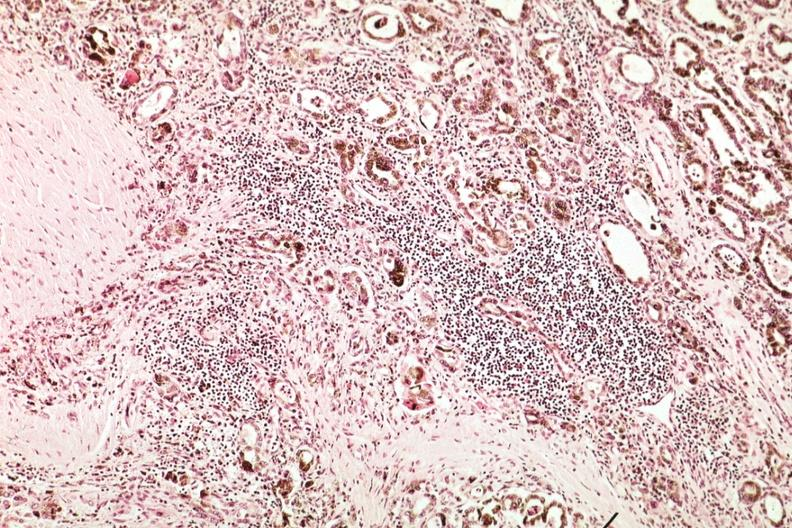what is present?
Answer the question using a single word or phrase. Endocrine 